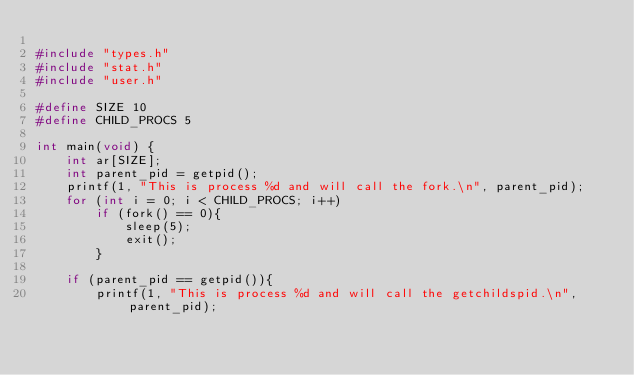<code> <loc_0><loc_0><loc_500><loc_500><_C_>
#include "types.h"
#include "stat.h"
#include "user.h"

#define SIZE 10
#define CHILD_PROCS 5

int main(void) {
    int ar[SIZE];
    int parent_pid = getpid();
    printf(1, "This is process %d and will call the fork.\n", parent_pid);
    for (int i = 0; i < CHILD_PROCS; i++)
        if (fork() == 0){
            sleep(5);
            exit();
        }
    
    if (parent_pid == getpid()){
        printf(1, "This is process %d and will call the getchildspid.\n", parent_pid);</code> 